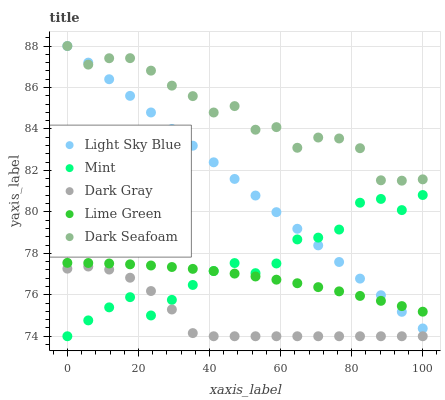Does Dark Gray have the minimum area under the curve?
Answer yes or no. Yes. Does Dark Seafoam have the maximum area under the curve?
Answer yes or no. Yes. Does Lime Green have the minimum area under the curve?
Answer yes or no. No. Does Lime Green have the maximum area under the curve?
Answer yes or no. No. Is Light Sky Blue the smoothest?
Answer yes or no. Yes. Is Dark Seafoam the roughest?
Answer yes or no. Yes. Is Lime Green the smoothest?
Answer yes or no. No. Is Lime Green the roughest?
Answer yes or no. No. Does Dark Gray have the lowest value?
Answer yes or no. Yes. Does Lime Green have the lowest value?
Answer yes or no. No. Does Light Sky Blue have the highest value?
Answer yes or no. Yes. Does Lime Green have the highest value?
Answer yes or no. No. Is Dark Gray less than Dark Seafoam?
Answer yes or no. Yes. Is Lime Green greater than Dark Gray?
Answer yes or no. Yes. Does Light Sky Blue intersect Mint?
Answer yes or no. Yes. Is Light Sky Blue less than Mint?
Answer yes or no. No. Is Light Sky Blue greater than Mint?
Answer yes or no. No. Does Dark Gray intersect Dark Seafoam?
Answer yes or no. No. 